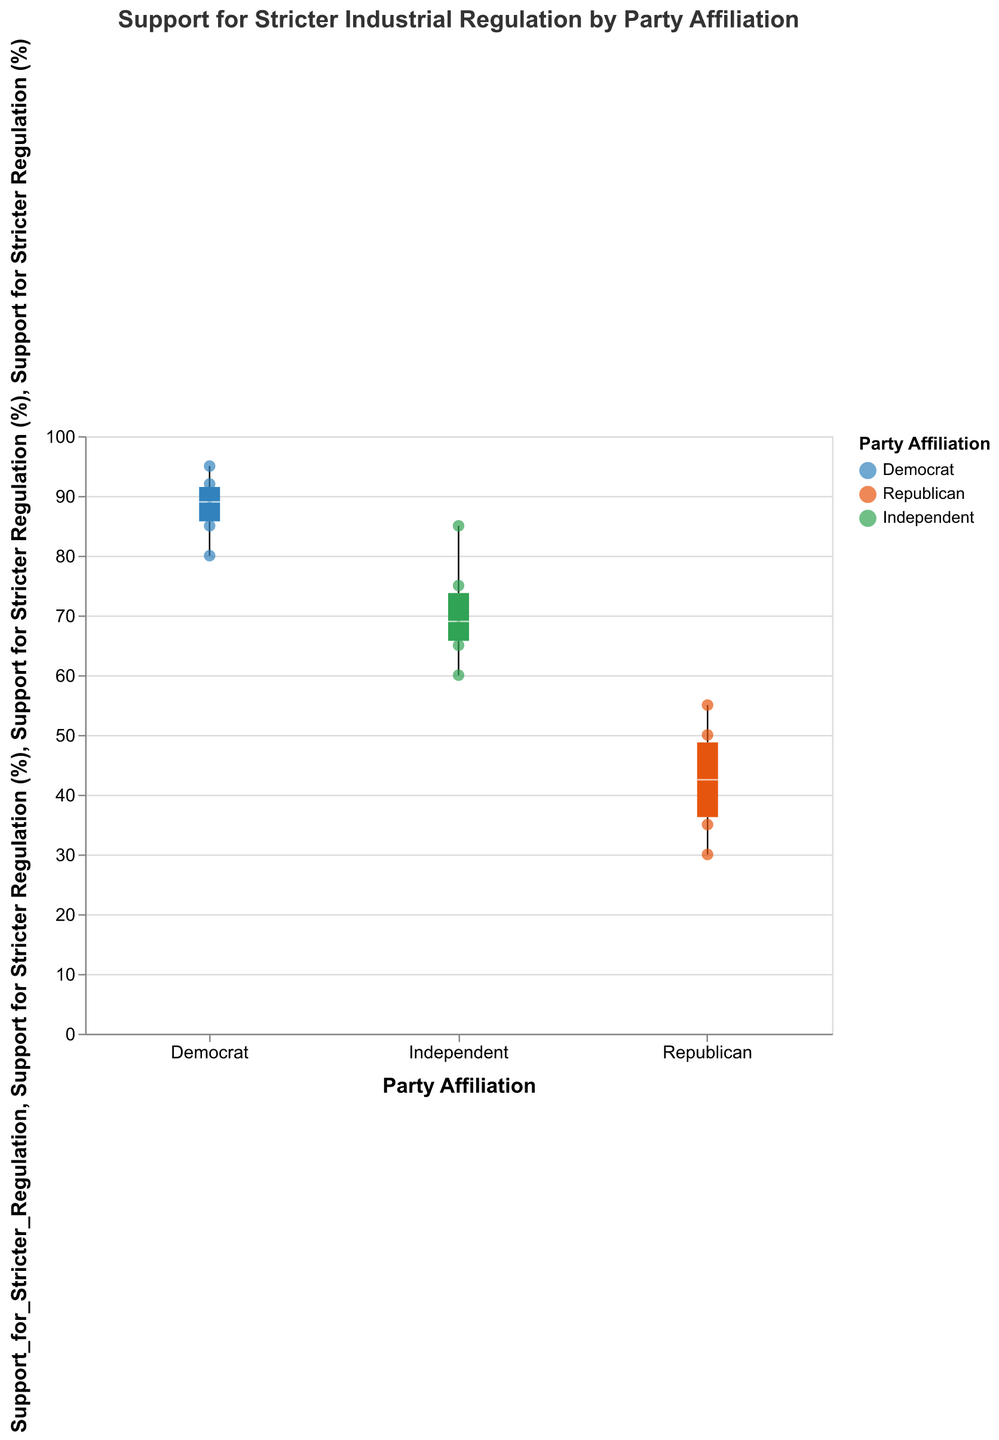What is the title of the chart? The title of the chart is located at the top center and provides a description of the visualization.
Answer: Support for Stricter Industrial Regulation by Party Affiliation What is the support percentage range on the y-axis? The y-axis shows the range of support percentages, which starts at 0% and goes up to 100% as indicated by the scale.
Answer: 0% to 100% Which party shows the highest median support for stricter regulation? Looking at the boxplots, the median value is typically represented by a line within each box. The Democrat boxplot has the highest median value compared with Republican and Independent.
Answer: Democrat Which party has the widest range of support for stricter regulation? The range is given by the distance between the minimum and maximum values on the boxplots. The Republican boxplot appears to span the largest range of values.
Answer: Republican What is the median support percentage for Independents? The median is represented by a line inside the box in a boxplot. For Independents, this line appears to be around the 70% mark.
Answer: 70% Between which parties is the difference in median support the largest? By observing the median lines of each boxplot, the largest difference is between Democrats and Republicans. The Democrat's median is around 90%, while the Republican's median is closer to 40%. Therefore, the difference is approximately 50%.
Answer: Democrats and Republicans Are there any outlier points in the Republican data set? If so, how many? Outliers in boxplots are often indicated by points that lie outside the whiskers. In the Republican data, there is at least one point outside the whisker on the higher end.
Answer: Yes, 1 What is the average median support across all party affiliations? To find the average median support, add the median values of Democrats (90%), Republicans (40%), and Independents (70%) and divide by 3. (90 + 40 + 70)/3 = 200/3 = 66.67%.
Answer: 66.67% How does the support for stricter regulation by Independents compare to Democrats on average? For comparison, examine the median lines: Independents have around 70% median support while Democrats have about 90%. Therefore, Democrats have a higher median support compared to Independents.
Answer: Democrats have higher support What can we infer about the variability in support for stricter regulation among different party affiliations? By examining the length of the whiskers and the range within the boxes, it can be inferred that Republicans show the highest variability, followed by Independents, with Democrats having the least variability. This shows Republicans are more divided on the issue, while Democrats are more unified.
Answer: Republicans show the highest variability 